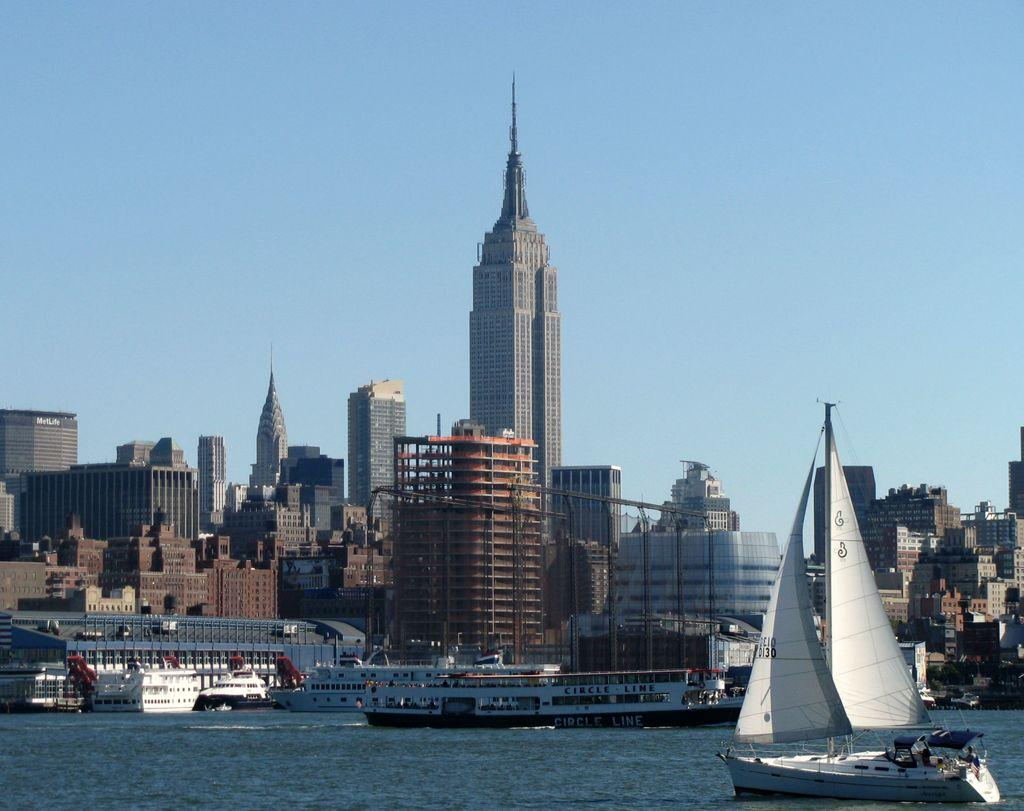What type of structures can be seen in the image? There are buildings in the image. What is located at the bottom of the image? There is water at the bottom of the image. What can be seen floating in the water? There is a boat and ships visible in the water. What part of the natural environment is visible in the image? The sky is visible in the background of the image. How many geese are flying over the buildings in the image? There are no geese visible in the image; it only features buildings, water, a boat, ships, and the sky. What type of property is being sold by the giants in the image? There are no giants or property for sale present in the image. 